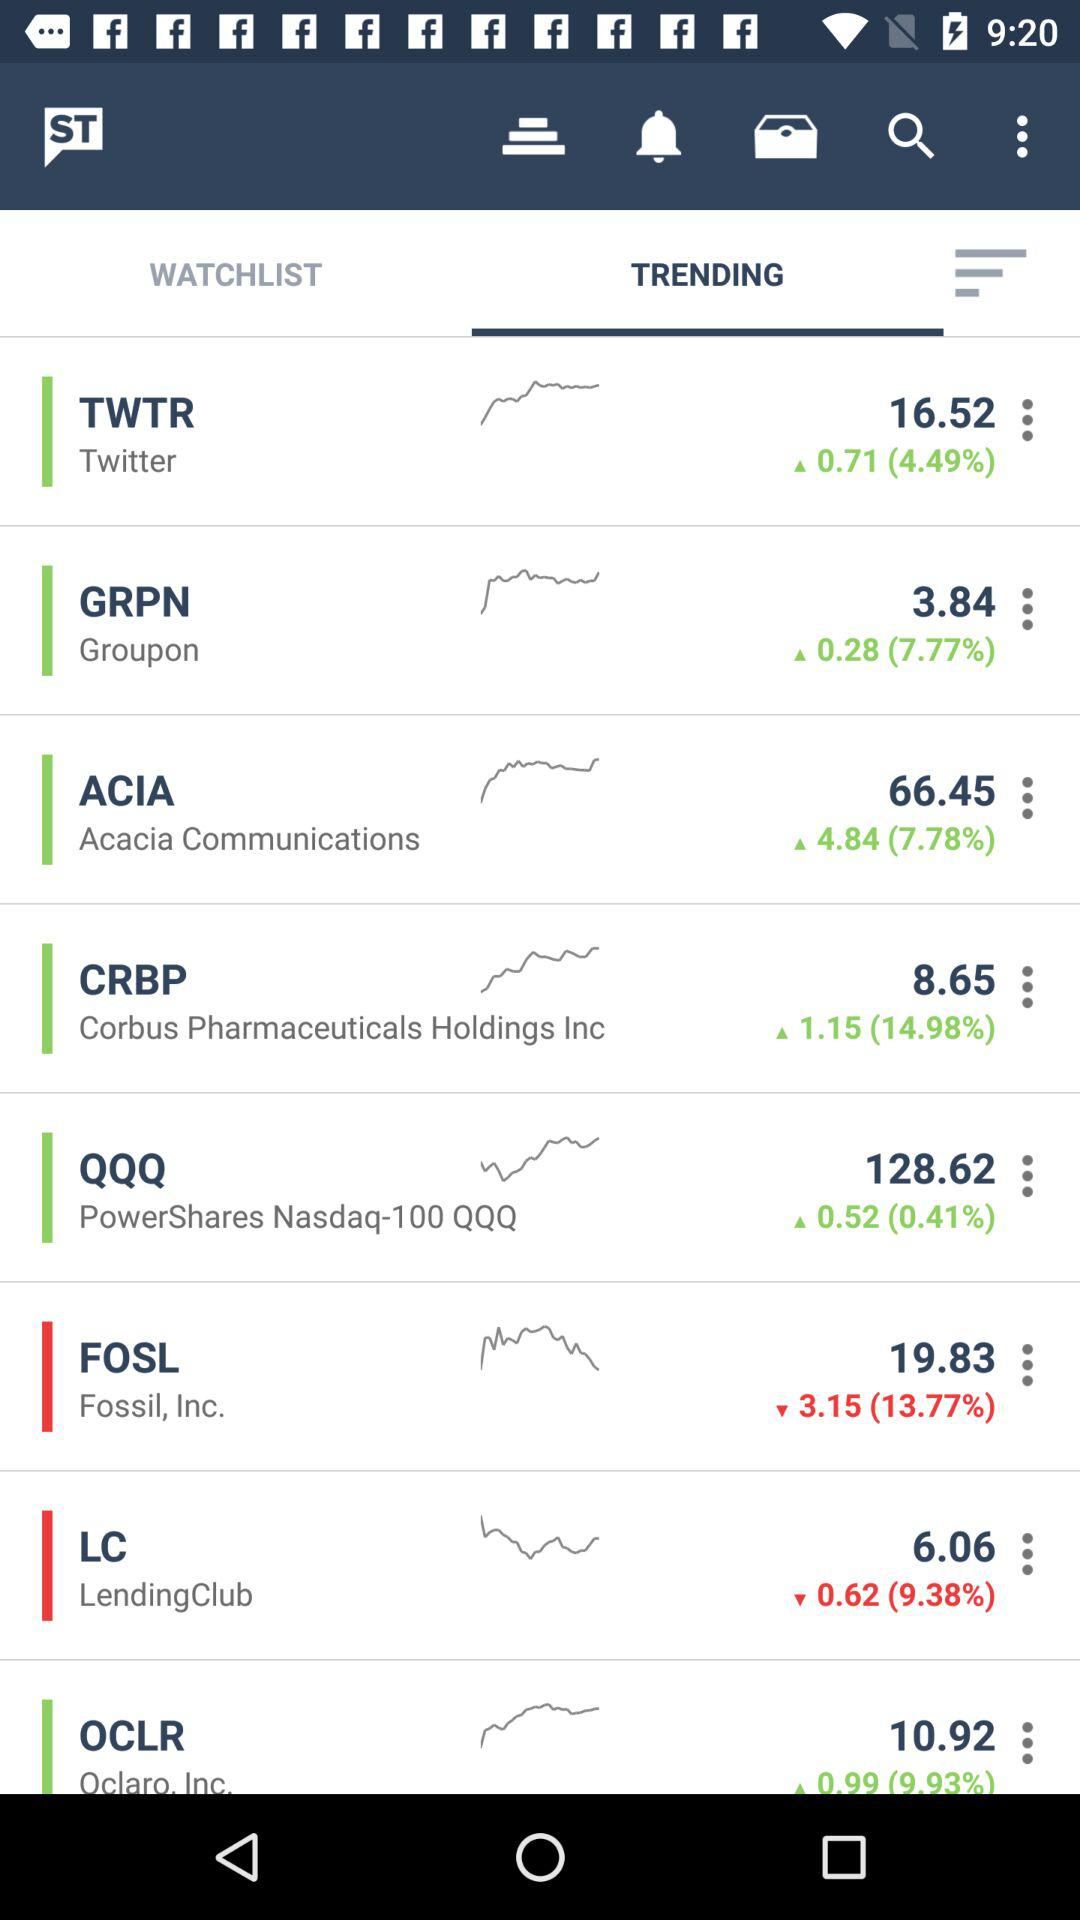Which tab is selected? The selected tab is "TRENDING". 